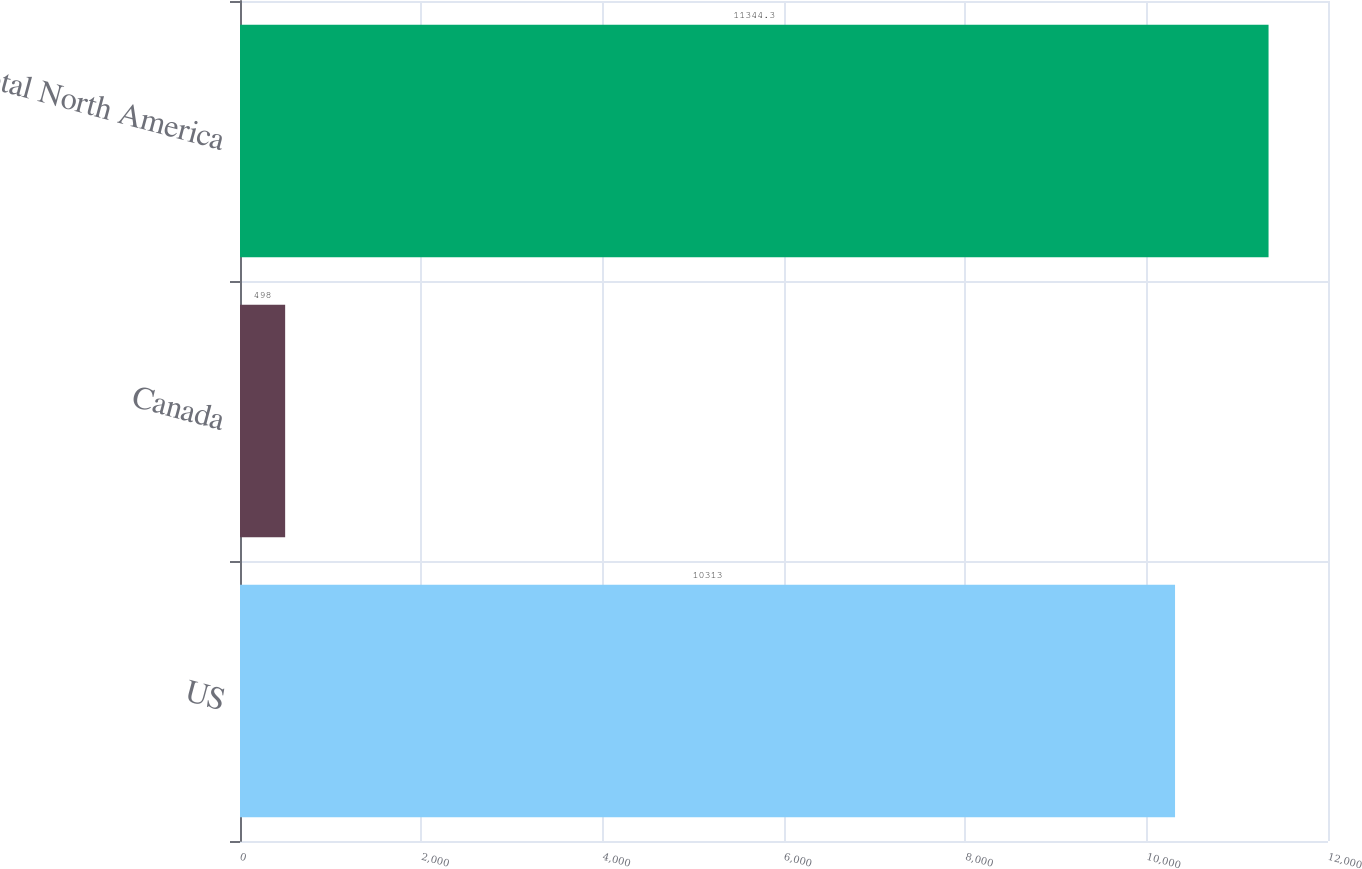Convert chart. <chart><loc_0><loc_0><loc_500><loc_500><bar_chart><fcel>US<fcel>Canada<fcel>Total North America<nl><fcel>10313<fcel>498<fcel>11344.3<nl></chart> 